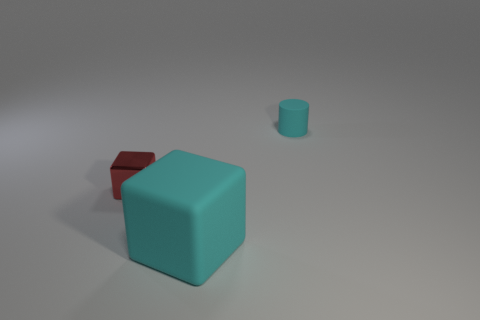How many other objects are the same material as the cylinder?
Make the answer very short. 1. Does the small matte cylinder have the same color as the big rubber thing?
Offer a very short reply. Yes. Is the number of tiny cyan matte cylinders in front of the cylinder less than the number of large rubber blocks?
Your answer should be very brief. Yes. What is the material of the big object that is the same color as the small cylinder?
Provide a short and direct response. Rubber. Does the big thing have the same material as the cylinder?
Provide a succinct answer. Yes. What number of other red things are made of the same material as the red thing?
Offer a very short reply. 0. The cylinder that is made of the same material as the big cyan cube is what color?
Give a very brief answer. Cyan. What shape is the small shiny object?
Offer a terse response. Cube. There is a cyan object in front of the tiny rubber cylinder; what is its material?
Ensure brevity in your answer.  Rubber. Are there any objects that have the same color as the big matte cube?
Your response must be concise. Yes. 